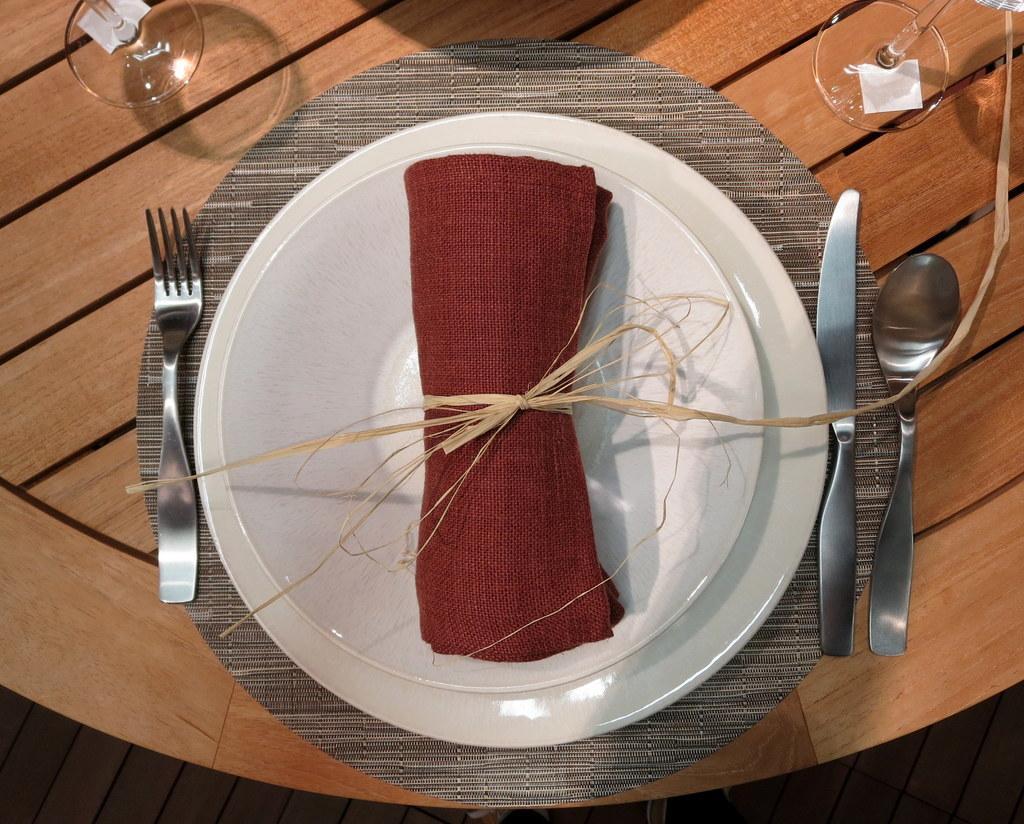Can you describe this image briefly? In this picture we can see a table, there is a plate, a knife, a spoon, a fork and two glasses present on the table, we can see a cloth in this plate. 